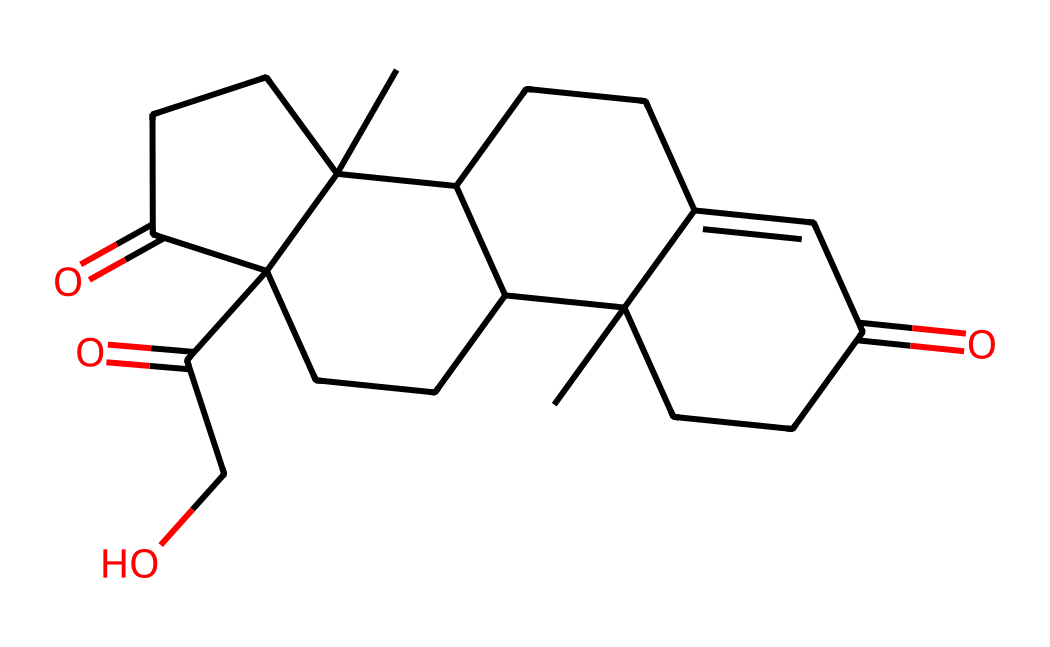What is the molecular formula of this chemical? To decipher the molecular formula, we can analyze the SMILES representation to count the number of each type of atom. Inspecting the structure, we can identify the following atoms: carbons (C), hydrogens (H), and oxygens (O). The structure shows 21 carbon atoms, 30 hydrogen atoms, and 5 oxygen atoms, leading us to the formula C21H30O5.
Answer: C21H30O5 How many rings are present in this chemical structure? By examining the SMILES structure, we can identify the numerical indicators within the representation that indicate ring closures (the numbered atoms). Each pair of the same number marks the edges of a cycloalkane. Counting these, we see there are four distinct rings formed in the structure.
Answer: 4 What type of hormone is this molecule categorized as? Analyzing the structure and its properties, this molecule is identifiable as a steroid hormone because it contains a four-ring core structure typical of steroids. Its functions in the body, such as stress regulation, further classify it specifically as a glucocorticoid hormone.
Answer: glucocorticoid What impact does this chemical have on the body during stress? This chemical, cortisol, plays a crucial role in the body's response to stress. It helps regulate metabolism, immune response, and maintain homeostasis. Primarily, it increases blood sugar levels and suppresses the immune response during stress situations to provide the body with energy.
Answer: increases blood sugar How does the presence of oxygen atoms influence the function of this hormone? The presence of oxygen atoms in the chemical structure of cortisol contributes to its polar nature, which is essential for its biological activity. Oxygen atoms impact the hormone's solubility and ability to bind to glucocorticoid receptors, facilitating its action in regulating stress responses.
Answer: enhances solubility What happens to cortisol levels during intense physical activity? When a person engages in intense physical activity, levels of cortisol typically increase. This elevation serves to provide energy by mobilizing glucose and fatty acids, enabling the body to cope with demands during strenuous exercise.
Answer: increase 